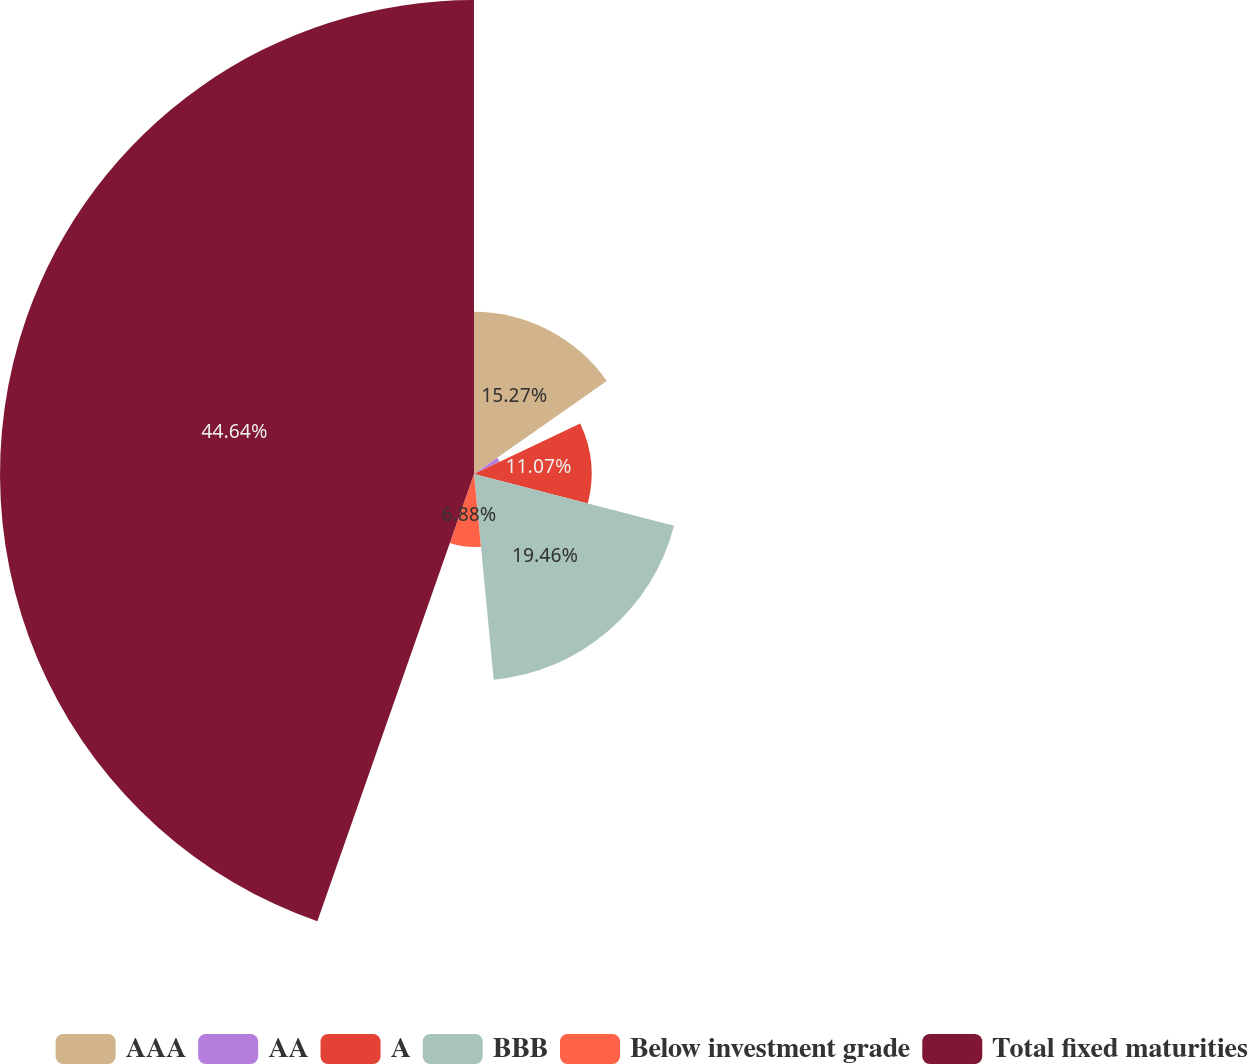Convert chart. <chart><loc_0><loc_0><loc_500><loc_500><pie_chart><fcel>AAA<fcel>AA<fcel>A<fcel>BBB<fcel>Below investment grade<fcel>Total fixed maturities<nl><fcel>15.27%<fcel>2.68%<fcel>11.07%<fcel>19.46%<fcel>6.88%<fcel>44.64%<nl></chart> 